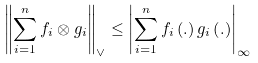Convert formula to latex. <formula><loc_0><loc_0><loc_500><loc_500>\left \| \sum _ { i = 1 } ^ { n } f _ { i } \otimes g _ { i } \right \| _ { \vee } \leq \left | \sum _ { i = 1 } ^ { n } f _ { i } \left ( . \right ) g _ { i } \left ( . \right ) \right | _ { \infty }</formula> 